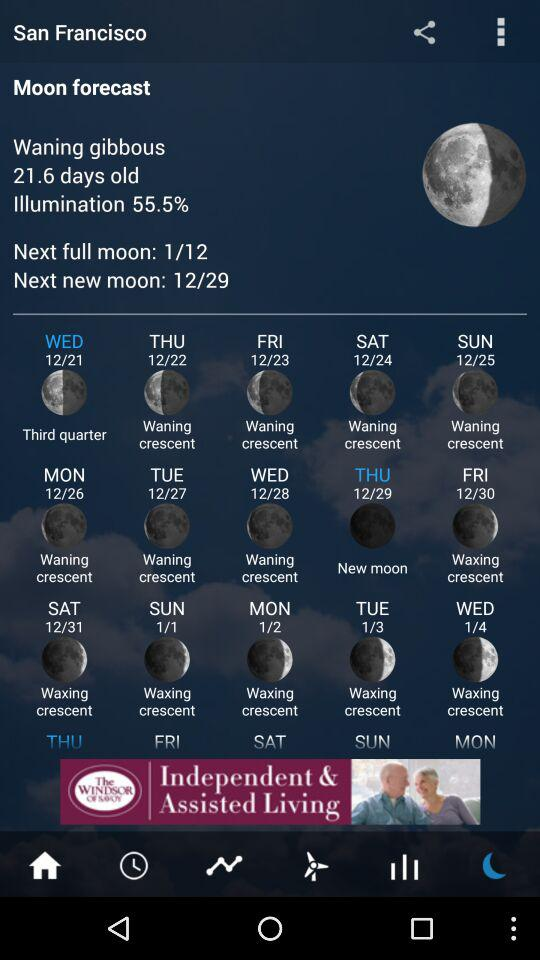How many days are there between the waning crescent moon on 12/24 and the waxing crescent moon on 1/4? There are 11 days between the waning crescent moon on December 24th and the waxing crescent moon on January 4th. The lunar phases change approximately every 29.5 days, so it's fascinating to track how the moon's appearance shifts over this period. 